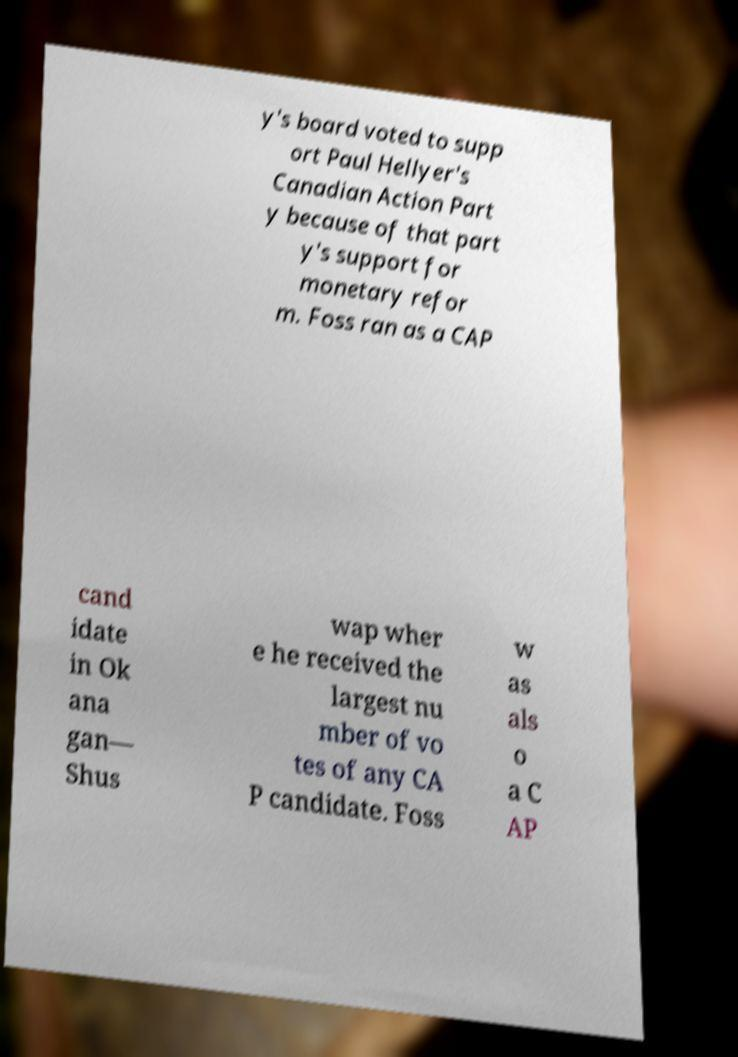I need the written content from this picture converted into text. Can you do that? y's board voted to supp ort Paul Hellyer's Canadian Action Part y because of that part y's support for monetary refor m. Foss ran as a CAP cand idate in Ok ana gan— Shus wap wher e he received the largest nu mber of vo tes of any CA P candidate. Foss w as als o a C AP 